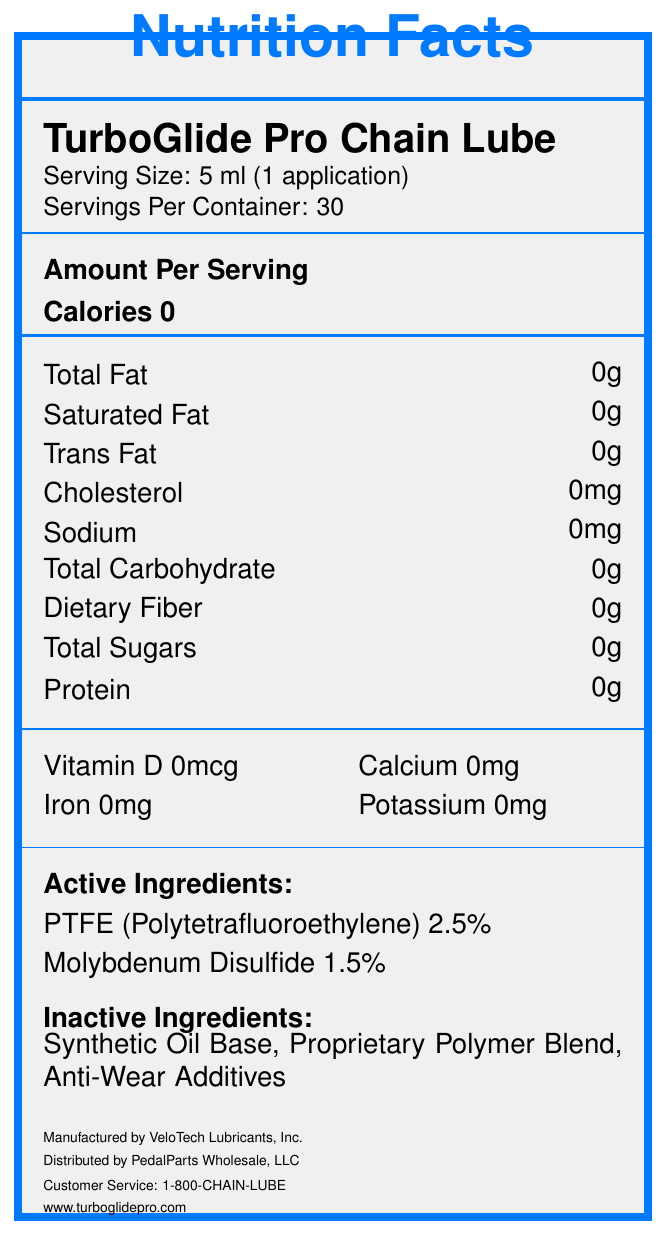what is the product name? The document clearly states the product name as "TurboGlide Pro Chain Lube."
Answer: TurboGlide Pro Chain Lube how many servings per container are there? The label specifies that there are 30 servings per container.
Answer: 30 what is the serving size? The serving size is listed as "5 ml (1 application)."
Answer: 5 ml (1 application) does the product contain any calories? The document shows "Calories 0," indicating that the product contains no calories.
Answer: No name one active ingredient The document lists PTFE (Polytetrafluoroethylene) as one of the active ingredients.
Answer: PTFE (Polytetrafluoroethylene) what are the performance benefits of this product? The document mentions these three performance benefits under the section "performance_benefits."
Answer: Reduces friction by 40%, Extends chain life up to 3x, Repels water and dirt which of the following is NOT an inactive ingredient? A. Synthetic Oil Base B. Anti-Wear Additives C. Molybdenum Disulfide Molybdenum Disulfide is listed as an active ingredient, not an inactive ingredient.
Answer: C. Molybdenum Disulfide how often should the product be re-applied? A. Every 50-75 miles B. Every 100-150 miles C. Every 200-300 miles According to the application instructions, the product should be re-applied every 100-150 miles or after exposure to wet conditions.
Answer: B. Every 100-150 miles is this product suitable for indigestion relief? The document contains warnings such as "For external use only" and "Do not ingest," making it clear that the product is not meant for indigestion relief.
Answer: No give a brief summary of the document This summary covers the main sections of the document, giving an overview of all the crucial details provided.
Answer: The document is a Nutrition Facts Label for TurboGlide Pro Chain Lube. It provides information on serving sizes, ingredients (both active and inactive), and nutrition details. It also details the application instructions, performance benefits, warnings, storage instructions, and manufacturer information. what is the phone number for customer service? The customer service phone number is listed at the bottom of the document.
Answer: 1-800-CHAIN-LUBE can the exact proprietary polymer blend be identified? The document only lists "Proprietary Polymer Blend" without any detailed information, so the exact composition cannot be determined.
Answer: Cannot be determined 